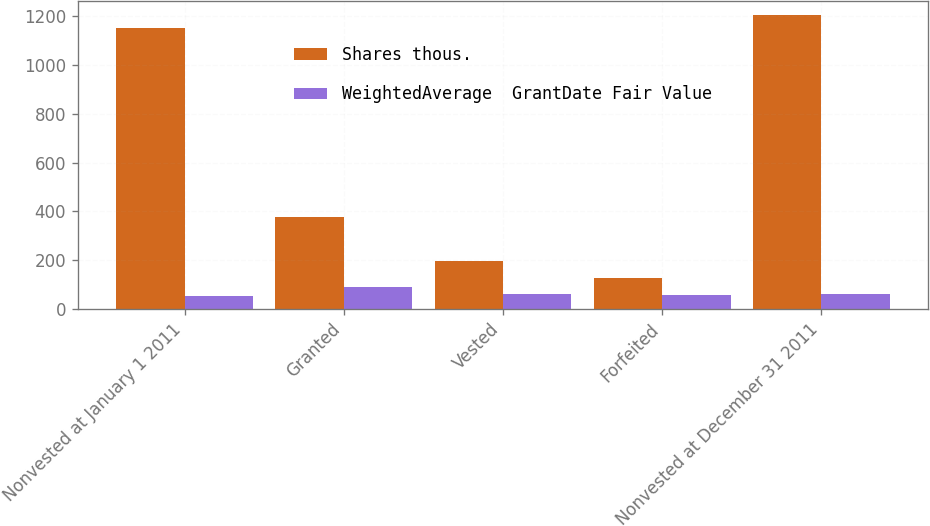Convert chart to OTSL. <chart><loc_0><loc_0><loc_500><loc_500><stacked_bar_chart><ecel><fcel>Nonvested at January 1 2011<fcel>Granted<fcel>Vested<fcel>Forfeited<fcel>Nonvested at December 31 2011<nl><fcel>Shares thous.<fcel>1151<fcel>376<fcel>195<fcel>128<fcel>1204<nl><fcel>WeightedAverage  GrantDate Fair Value<fcel>53.93<fcel>89.87<fcel>60.16<fcel>58.89<fcel>63.62<nl></chart> 